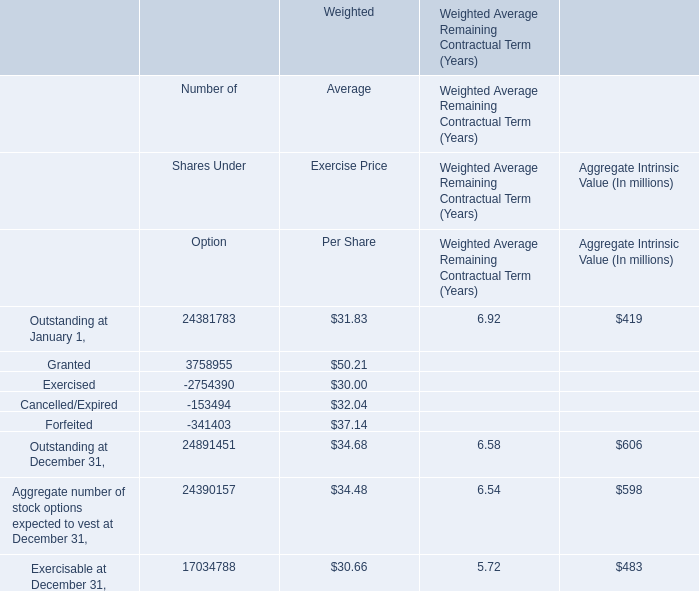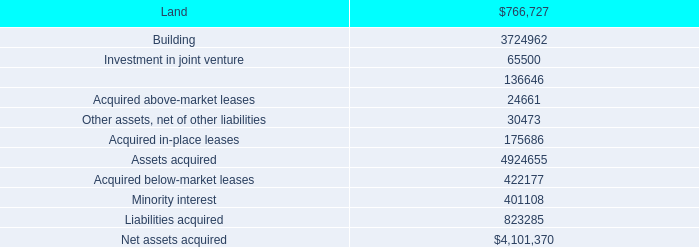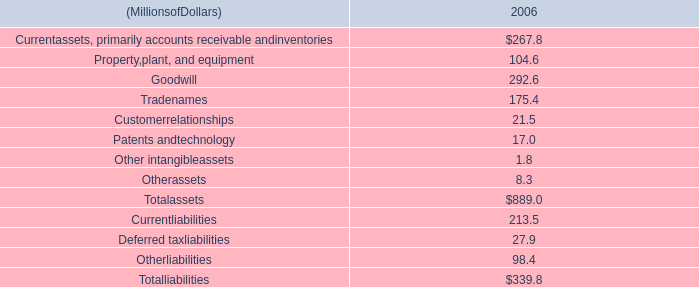What's the 20 % of total elements for Aggregate Intrinsic Value? (in million) 
Computations: ((((419 + 606) + 598) + 483) * 0.2)
Answer: 421.2. 